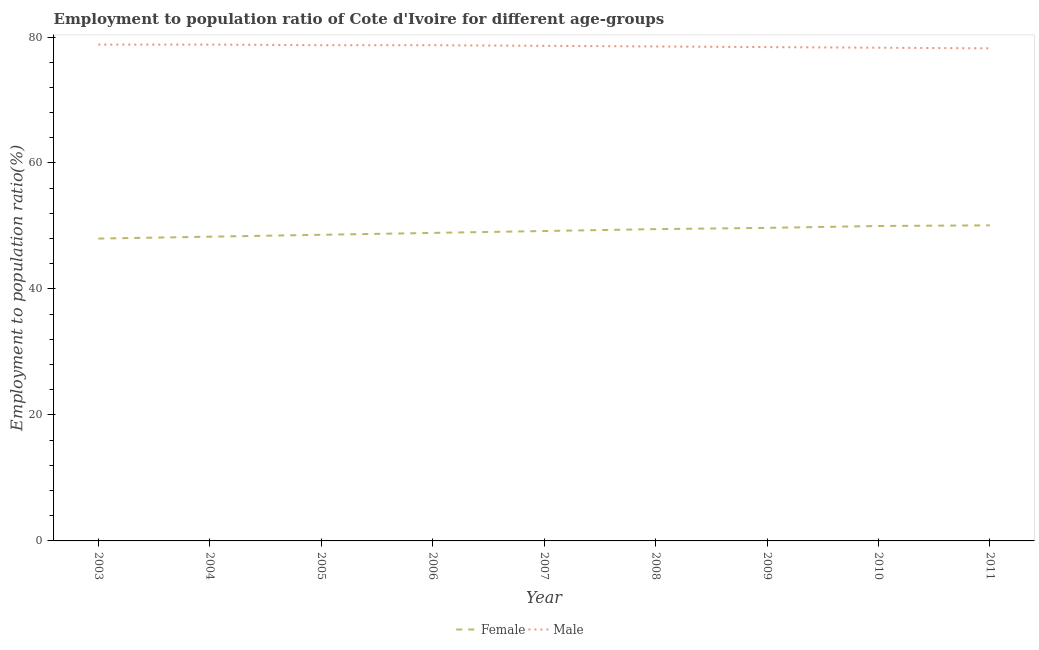Does the line corresponding to employment to population ratio(male) intersect with the line corresponding to employment to population ratio(female)?
Ensure brevity in your answer.  No. Is the number of lines equal to the number of legend labels?
Offer a very short reply. Yes. What is the employment to population ratio(male) in 2011?
Keep it short and to the point. 78.2. Across all years, what is the maximum employment to population ratio(female)?
Your answer should be very brief. 50.1. Across all years, what is the minimum employment to population ratio(male)?
Keep it short and to the point. 78.2. In which year was the employment to population ratio(female) maximum?
Provide a short and direct response. 2011. What is the total employment to population ratio(female) in the graph?
Your answer should be very brief. 442.3. What is the difference between the employment to population ratio(male) in 2007 and that in 2008?
Ensure brevity in your answer.  0.1. What is the difference between the employment to population ratio(female) in 2005 and the employment to population ratio(male) in 2010?
Your answer should be very brief. -29.7. What is the average employment to population ratio(female) per year?
Offer a terse response. 49.14. In the year 2005, what is the difference between the employment to population ratio(female) and employment to population ratio(male)?
Offer a terse response. -30.1. In how many years, is the employment to population ratio(female) greater than 56 %?
Provide a short and direct response. 0. What is the ratio of the employment to population ratio(female) in 2004 to that in 2006?
Give a very brief answer. 0.99. What is the difference between the highest and the lowest employment to population ratio(male)?
Your response must be concise. 0.6. Is the sum of the employment to population ratio(female) in 2003 and 2010 greater than the maximum employment to population ratio(male) across all years?
Give a very brief answer. Yes. Does the employment to population ratio(female) monotonically increase over the years?
Keep it short and to the point. Yes. Is the employment to population ratio(male) strictly greater than the employment to population ratio(female) over the years?
Ensure brevity in your answer.  Yes. Is the employment to population ratio(female) strictly less than the employment to population ratio(male) over the years?
Offer a terse response. Yes. How many lines are there?
Ensure brevity in your answer.  2. How many years are there in the graph?
Provide a short and direct response. 9. What is the difference between two consecutive major ticks on the Y-axis?
Offer a terse response. 20. Are the values on the major ticks of Y-axis written in scientific E-notation?
Ensure brevity in your answer.  No. Does the graph contain any zero values?
Offer a very short reply. No. Where does the legend appear in the graph?
Make the answer very short. Bottom center. How are the legend labels stacked?
Your answer should be very brief. Horizontal. What is the title of the graph?
Ensure brevity in your answer.  Employment to population ratio of Cote d'Ivoire for different age-groups. Does "Travel services" appear as one of the legend labels in the graph?
Your response must be concise. No. What is the Employment to population ratio(%) of Male in 2003?
Make the answer very short. 78.8. What is the Employment to population ratio(%) of Female in 2004?
Make the answer very short. 48.3. What is the Employment to population ratio(%) in Male in 2004?
Keep it short and to the point. 78.8. What is the Employment to population ratio(%) in Female in 2005?
Your answer should be compact. 48.6. What is the Employment to population ratio(%) in Male in 2005?
Give a very brief answer. 78.7. What is the Employment to population ratio(%) of Female in 2006?
Provide a succinct answer. 48.9. What is the Employment to population ratio(%) in Male in 2006?
Make the answer very short. 78.7. What is the Employment to population ratio(%) of Female in 2007?
Your answer should be very brief. 49.2. What is the Employment to population ratio(%) of Male in 2007?
Provide a succinct answer. 78.6. What is the Employment to population ratio(%) in Female in 2008?
Offer a very short reply. 49.5. What is the Employment to population ratio(%) of Male in 2008?
Provide a short and direct response. 78.5. What is the Employment to population ratio(%) of Female in 2009?
Your answer should be compact. 49.7. What is the Employment to population ratio(%) in Male in 2009?
Offer a terse response. 78.4. What is the Employment to population ratio(%) in Female in 2010?
Provide a short and direct response. 50. What is the Employment to population ratio(%) of Male in 2010?
Provide a short and direct response. 78.3. What is the Employment to population ratio(%) in Female in 2011?
Provide a short and direct response. 50.1. What is the Employment to population ratio(%) of Male in 2011?
Keep it short and to the point. 78.2. Across all years, what is the maximum Employment to population ratio(%) of Female?
Provide a short and direct response. 50.1. Across all years, what is the maximum Employment to population ratio(%) of Male?
Offer a very short reply. 78.8. Across all years, what is the minimum Employment to population ratio(%) in Male?
Your answer should be compact. 78.2. What is the total Employment to population ratio(%) in Female in the graph?
Give a very brief answer. 442.3. What is the total Employment to population ratio(%) of Male in the graph?
Make the answer very short. 707. What is the difference between the Employment to population ratio(%) of Female in 2003 and that in 2005?
Offer a very short reply. -0.6. What is the difference between the Employment to population ratio(%) in Male in 2003 and that in 2006?
Ensure brevity in your answer.  0.1. What is the difference between the Employment to population ratio(%) in Female in 2003 and that in 2007?
Provide a succinct answer. -1.2. What is the difference between the Employment to population ratio(%) in Female in 2003 and that in 2008?
Your response must be concise. -1.5. What is the difference between the Employment to population ratio(%) of Male in 2003 and that in 2008?
Make the answer very short. 0.3. What is the difference between the Employment to population ratio(%) in Female in 2003 and that in 2009?
Ensure brevity in your answer.  -1.7. What is the difference between the Employment to population ratio(%) of Female in 2004 and that in 2005?
Keep it short and to the point. -0.3. What is the difference between the Employment to population ratio(%) of Male in 2004 and that in 2005?
Offer a very short reply. 0.1. What is the difference between the Employment to population ratio(%) of Female in 2004 and that in 2006?
Offer a terse response. -0.6. What is the difference between the Employment to population ratio(%) in Male in 2004 and that in 2006?
Ensure brevity in your answer.  0.1. What is the difference between the Employment to population ratio(%) of Female in 2004 and that in 2007?
Make the answer very short. -0.9. What is the difference between the Employment to population ratio(%) of Female in 2004 and that in 2008?
Provide a short and direct response. -1.2. What is the difference between the Employment to population ratio(%) of Male in 2004 and that in 2008?
Your answer should be compact. 0.3. What is the difference between the Employment to population ratio(%) in Male in 2004 and that in 2009?
Ensure brevity in your answer.  0.4. What is the difference between the Employment to population ratio(%) in Male in 2004 and that in 2010?
Give a very brief answer. 0.5. What is the difference between the Employment to population ratio(%) of Male in 2005 and that in 2006?
Ensure brevity in your answer.  0. What is the difference between the Employment to population ratio(%) in Female in 2005 and that in 2007?
Your answer should be compact. -0.6. What is the difference between the Employment to population ratio(%) of Male in 2005 and that in 2007?
Your answer should be compact. 0.1. What is the difference between the Employment to population ratio(%) in Female in 2005 and that in 2008?
Provide a short and direct response. -0.9. What is the difference between the Employment to population ratio(%) in Male in 2005 and that in 2008?
Provide a succinct answer. 0.2. What is the difference between the Employment to population ratio(%) of Male in 2005 and that in 2011?
Provide a short and direct response. 0.5. What is the difference between the Employment to population ratio(%) of Male in 2006 and that in 2008?
Ensure brevity in your answer.  0.2. What is the difference between the Employment to population ratio(%) of Male in 2006 and that in 2009?
Provide a short and direct response. 0.3. What is the difference between the Employment to population ratio(%) of Male in 2006 and that in 2010?
Offer a terse response. 0.4. What is the difference between the Employment to population ratio(%) in Male in 2006 and that in 2011?
Keep it short and to the point. 0.5. What is the difference between the Employment to population ratio(%) in Female in 2007 and that in 2009?
Give a very brief answer. -0.5. What is the difference between the Employment to population ratio(%) of Male in 2007 and that in 2009?
Your answer should be compact. 0.2. What is the difference between the Employment to population ratio(%) in Male in 2007 and that in 2010?
Provide a succinct answer. 0.3. What is the difference between the Employment to population ratio(%) of Female in 2007 and that in 2011?
Provide a short and direct response. -0.9. What is the difference between the Employment to population ratio(%) in Male in 2007 and that in 2011?
Provide a succinct answer. 0.4. What is the difference between the Employment to population ratio(%) of Female in 2008 and that in 2009?
Provide a short and direct response. -0.2. What is the difference between the Employment to population ratio(%) of Female in 2008 and that in 2010?
Your answer should be very brief. -0.5. What is the difference between the Employment to population ratio(%) of Male in 2008 and that in 2010?
Keep it short and to the point. 0.2. What is the difference between the Employment to population ratio(%) in Male in 2008 and that in 2011?
Your answer should be very brief. 0.3. What is the difference between the Employment to population ratio(%) of Male in 2009 and that in 2010?
Your answer should be very brief. 0.1. What is the difference between the Employment to population ratio(%) in Male in 2009 and that in 2011?
Provide a short and direct response. 0.2. What is the difference between the Employment to population ratio(%) of Female in 2003 and the Employment to population ratio(%) of Male in 2004?
Ensure brevity in your answer.  -30.8. What is the difference between the Employment to population ratio(%) in Female in 2003 and the Employment to population ratio(%) in Male in 2005?
Offer a very short reply. -30.7. What is the difference between the Employment to population ratio(%) of Female in 2003 and the Employment to population ratio(%) of Male in 2006?
Provide a succinct answer. -30.7. What is the difference between the Employment to population ratio(%) of Female in 2003 and the Employment to population ratio(%) of Male in 2007?
Give a very brief answer. -30.6. What is the difference between the Employment to population ratio(%) in Female in 2003 and the Employment to population ratio(%) in Male in 2008?
Your answer should be very brief. -30.5. What is the difference between the Employment to population ratio(%) of Female in 2003 and the Employment to population ratio(%) of Male in 2009?
Make the answer very short. -30.4. What is the difference between the Employment to population ratio(%) of Female in 2003 and the Employment to population ratio(%) of Male in 2010?
Give a very brief answer. -30.3. What is the difference between the Employment to population ratio(%) of Female in 2003 and the Employment to population ratio(%) of Male in 2011?
Provide a succinct answer. -30.2. What is the difference between the Employment to population ratio(%) in Female in 2004 and the Employment to population ratio(%) in Male in 2005?
Provide a succinct answer. -30.4. What is the difference between the Employment to population ratio(%) of Female in 2004 and the Employment to population ratio(%) of Male in 2006?
Make the answer very short. -30.4. What is the difference between the Employment to population ratio(%) of Female in 2004 and the Employment to population ratio(%) of Male in 2007?
Ensure brevity in your answer.  -30.3. What is the difference between the Employment to population ratio(%) in Female in 2004 and the Employment to population ratio(%) in Male in 2008?
Your answer should be compact. -30.2. What is the difference between the Employment to population ratio(%) of Female in 2004 and the Employment to population ratio(%) of Male in 2009?
Offer a terse response. -30.1. What is the difference between the Employment to population ratio(%) in Female in 2004 and the Employment to population ratio(%) in Male in 2010?
Offer a terse response. -30. What is the difference between the Employment to population ratio(%) of Female in 2004 and the Employment to population ratio(%) of Male in 2011?
Your answer should be compact. -29.9. What is the difference between the Employment to population ratio(%) in Female in 2005 and the Employment to population ratio(%) in Male in 2006?
Make the answer very short. -30.1. What is the difference between the Employment to population ratio(%) in Female in 2005 and the Employment to population ratio(%) in Male in 2008?
Provide a short and direct response. -29.9. What is the difference between the Employment to population ratio(%) of Female in 2005 and the Employment to population ratio(%) of Male in 2009?
Provide a short and direct response. -29.8. What is the difference between the Employment to population ratio(%) of Female in 2005 and the Employment to population ratio(%) of Male in 2010?
Ensure brevity in your answer.  -29.7. What is the difference between the Employment to population ratio(%) of Female in 2005 and the Employment to population ratio(%) of Male in 2011?
Your answer should be compact. -29.6. What is the difference between the Employment to population ratio(%) in Female in 2006 and the Employment to population ratio(%) in Male in 2007?
Your response must be concise. -29.7. What is the difference between the Employment to population ratio(%) in Female in 2006 and the Employment to population ratio(%) in Male in 2008?
Ensure brevity in your answer.  -29.6. What is the difference between the Employment to population ratio(%) in Female in 2006 and the Employment to population ratio(%) in Male in 2009?
Give a very brief answer. -29.5. What is the difference between the Employment to population ratio(%) of Female in 2006 and the Employment to population ratio(%) of Male in 2010?
Your answer should be very brief. -29.4. What is the difference between the Employment to population ratio(%) in Female in 2006 and the Employment to population ratio(%) in Male in 2011?
Your answer should be compact. -29.3. What is the difference between the Employment to population ratio(%) of Female in 2007 and the Employment to population ratio(%) of Male in 2008?
Provide a succinct answer. -29.3. What is the difference between the Employment to population ratio(%) in Female in 2007 and the Employment to population ratio(%) in Male in 2009?
Provide a short and direct response. -29.2. What is the difference between the Employment to population ratio(%) in Female in 2007 and the Employment to population ratio(%) in Male in 2010?
Your response must be concise. -29.1. What is the difference between the Employment to population ratio(%) in Female in 2008 and the Employment to population ratio(%) in Male in 2009?
Offer a terse response. -28.9. What is the difference between the Employment to population ratio(%) of Female in 2008 and the Employment to population ratio(%) of Male in 2010?
Your response must be concise. -28.8. What is the difference between the Employment to population ratio(%) in Female in 2008 and the Employment to population ratio(%) in Male in 2011?
Keep it short and to the point. -28.7. What is the difference between the Employment to population ratio(%) of Female in 2009 and the Employment to population ratio(%) of Male in 2010?
Provide a succinct answer. -28.6. What is the difference between the Employment to population ratio(%) in Female in 2009 and the Employment to population ratio(%) in Male in 2011?
Ensure brevity in your answer.  -28.5. What is the difference between the Employment to population ratio(%) of Female in 2010 and the Employment to population ratio(%) of Male in 2011?
Your answer should be compact. -28.2. What is the average Employment to population ratio(%) of Female per year?
Your response must be concise. 49.14. What is the average Employment to population ratio(%) of Male per year?
Keep it short and to the point. 78.56. In the year 2003, what is the difference between the Employment to population ratio(%) of Female and Employment to population ratio(%) of Male?
Make the answer very short. -30.8. In the year 2004, what is the difference between the Employment to population ratio(%) in Female and Employment to population ratio(%) in Male?
Give a very brief answer. -30.5. In the year 2005, what is the difference between the Employment to population ratio(%) in Female and Employment to population ratio(%) in Male?
Your answer should be compact. -30.1. In the year 2006, what is the difference between the Employment to population ratio(%) in Female and Employment to population ratio(%) in Male?
Your answer should be compact. -29.8. In the year 2007, what is the difference between the Employment to population ratio(%) in Female and Employment to population ratio(%) in Male?
Make the answer very short. -29.4. In the year 2008, what is the difference between the Employment to population ratio(%) of Female and Employment to population ratio(%) of Male?
Make the answer very short. -29. In the year 2009, what is the difference between the Employment to population ratio(%) of Female and Employment to population ratio(%) of Male?
Ensure brevity in your answer.  -28.7. In the year 2010, what is the difference between the Employment to population ratio(%) in Female and Employment to population ratio(%) in Male?
Give a very brief answer. -28.3. In the year 2011, what is the difference between the Employment to population ratio(%) in Female and Employment to population ratio(%) in Male?
Provide a short and direct response. -28.1. What is the ratio of the Employment to population ratio(%) of Female in 2003 to that in 2004?
Give a very brief answer. 0.99. What is the ratio of the Employment to population ratio(%) of Male in 2003 to that in 2004?
Your response must be concise. 1. What is the ratio of the Employment to population ratio(%) in Female in 2003 to that in 2005?
Offer a very short reply. 0.99. What is the ratio of the Employment to population ratio(%) in Female in 2003 to that in 2006?
Your answer should be very brief. 0.98. What is the ratio of the Employment to population ratio(%) of Female in 2003 to that in 2007?
Provide a short and direct response. 0.98. What is the ratio of the Employment to population ratio(%) of Female in 2003 to that in 2008?
Keep it short and to the point. 0.97. What is the ratio of the Employment to population ratio(%) in Female in 2003 to that in 2009?
Provide a succinct answer. 0.97. What is the ratio of the Employment to population ratio(%) of Male in 2003 to that in 2009?
Provide a short and direct response. 1.01. What is the ratio of the Employment to population ratio(%) in Female in 2003 to that in 2010?
Offer a very short reply. 0.96. What is the ratio of the Employment to population ratio(%) of Male in 2003 to that in 2010?
Give a very brief answer. 1.01. What is the ratio of the Employment to population ratio(%) of Female in 2003 to that in 2011?
Ensure brevity in your answer.  0.96. What is the ratio of the Employment to population ratio(%) in Male in 2003 to that in 2011?
Keep it short and to the point. 1.01. What is the ratio of the Employment to population ratio(%) in Female in 2004 to that in 2005?
Your response must be concise. 0.99. What is the ratio of the Employment to population ratio(%) in Female in 2004 to that in 2006?
Your answer should be very brief. 0.99. What is the ratio of the Employment to population ratio(%) of Male in 2004 to that in 2006?
Your answer should be compact. 1. What is the ratio of the Employment to population ratio(%) in Female in 2004 to that in 2007?
Ensure brevity in your answer.  0.98. What is the ratio of the Employment to population ratio(%) of Female in 2004 to that in 2008?
Your response must be concise. 0.98. What is the ratio of the Employment to population ratio(%) of Female in 2004 to that in 2009?
Provide a succinct answer. 0.97. What is the ratio of the Employment to population ratio(%) of Male in 2004 to that in 2009?
Give a very brief answer. 1.01. What is the ratio of the Employment to population ratio(%) of Male in 2004 to that in 2010?
Provide a short and direct response. 1.01. What is the ratio of the Employment to population ratio(%) in Female in 2004 to that in 2011?
Provide a short and direct response. 0.96. What is the ratio of the Employment to population ratio(%) of Male in 2004 to that in 2011?
Your answer should be very brief. 1.01. What is the ratio of the Employment to population ratio(%) in Male in 2005 to that in 2006?
Your answer should be compact. 1. What is the ratio of the Employment to population ratio(%) in Male in 2005 to that in 2007?
Keep it short and to the point. 1. What is the ratio of the Employment to population ratio(%) in Female in 2005 to that in 2008?
Keep it short and to the point. 0.98. What is the ratio of the Employment to population ratio(%) in Male in 2005 to that in 2008?
Ensure brevity in your answer.  1. What is the ratio of the Employment to population ratio(%) of Female in 2005 to that in 2009?
Offer a terse response. 0.98. What is the ratio of the Employment to population ratio(%) in Female in 2005 to that in 2010?
Your answer should be compact. 0.97. What is the ratio of the Employment to population ratio(%) of Male in 2005 to that in 2010?
Provide a succinct answer. 1.01. What is the ratio of the Employment to population ratio(%) in Female in 2005 to that in 2011?
Ensure brevity in your answer.  0.97. What is the ratio of the Employment to population ratio(%) of Male in 2005 to that in 2011?
Offer a very short reply. 1.01. What is the ratio of the Employment to population ratio(%) of Female in 2006 to that in 2007?
Provide a short and direct response. 0.99. What is the ratio of the Employment to population ratio(%) of Male in 2006 to that in 2007?
Keep it short and to the point. 1. What is the ratio of the Employment to population ratio(%) in Female in 2006 to that in 2008?
Provide a short and direct response. 0.99. What is the ratio of the Employment to population ratio(%) in Female in 2006 to that in 2009?
Your answer should be compact. 0.98. What is the ratio of the Employment to population ratio(%) of Male in 2006 to that in 2009?
Make the answer very short. 1. What is the ratio of the Employment to population ratio(%) in Female in 2006 to that in 2010?
Your answer should be compact. 0.98. What is the ratio of the Employment to population ratio(%) in Male in 2006 to that in 2010?
Provide a succinct answer. 1.01. What is the ratio of the Employment to population ratio(%) in Female in 2006 to that in 2011?
Your response must be concise. 0.98. What is the ratio of the Employment to population ratio(%) in Male in 2006 to that in 2011?
Make the answer very short. 1.01. What is the ratio of the Employment to population ratio(%) in Female in 2007 to that in 2008?
Ensure brevity in your answer.  0.99. What is the ratio of the Employment to population ratio(%) in Male in 2007 to that in 2008?
Your answer should be very brief. 1. What is the ratio of the Employment to population ratio(%) in Female in 2007 to that in 2010?
Offer a very short reply. 0.98. What is the ratio of the Employment to population ratio(%) of Male in 2007 to that in 2010?
Ensure brevity in your answer.  1. What is the ratio of the Employment to population ratio(%) of Female in 2007 to that in 2011?
Make the answer very short. 0.98. What is the ratio of the Employment to population ratio(%) in Female in 2008 to that in 2009?
Ensure brevity in your answer.  1. What is the ratio of the Employment to population ratio(%) in Female in 2008 to that in 2011?
Keep it short and to the point. 0.99. What is the ratio of the Employment to population ratio(%) in Female in 2009 to that in 2011?
Provide a succinct answer. 0.99. What is the ratio of the Employment to population ratio(%) in Male in 2010 to that in 2011?
Your response must be concise. 1. What is the difference between the highest and the second highest Employment to population ratio(%) of Female?
Keep it short and to the point. 0.1. What is the difference between the highest and the second highest Employment to population ratio(%) in Male?
Keep it short and to the point. 0. What is the difference between the highest and the lowest Employment to population ratio(%) of Female?
Your answer should be very brief. 2.1. What is the difference between the highest and the lowest Employment to population ratio(%) of Male?
Ensure brevity in your answer.  0.6. 